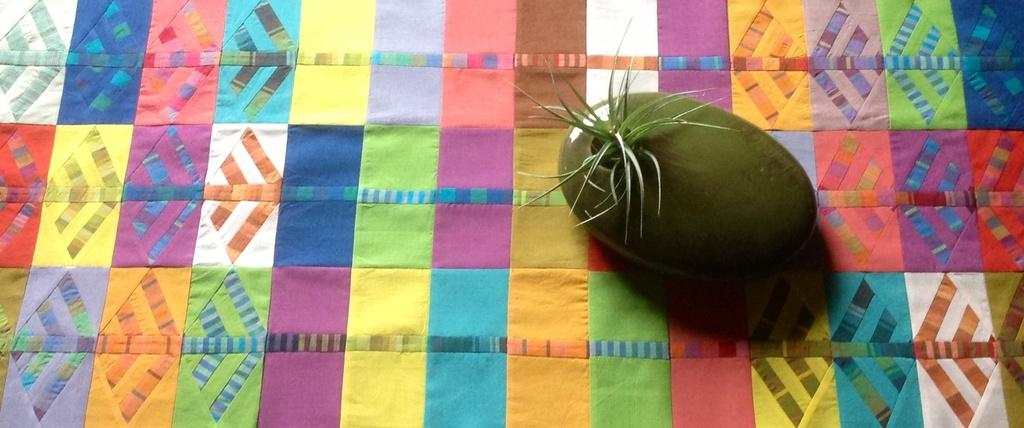What is the main object in the image? There is a colorful cloth in the image. What is placed on the colorful cloth? There is a houseplant on the cloth. What type of wheel can be seen on the houseplant in the image? There is no wheel present on the houseplant in the image. What advice can be given to the houseplant in the image? The image does not depict a living houseplant that can receive advice. 